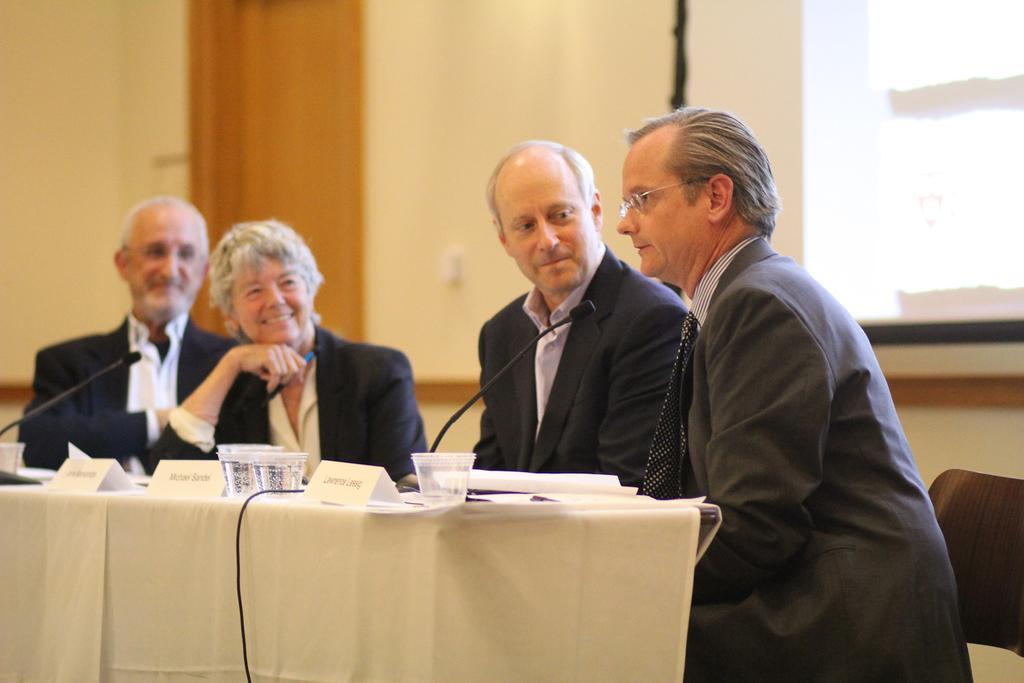Please provide a concise description of this image. There are three men and one woman sitting and smiling. This is the table covered with a cloth. I can see the name boards, glasses, papers and mikes on the table. This looks like a screen. In the background, I can see a wall. 